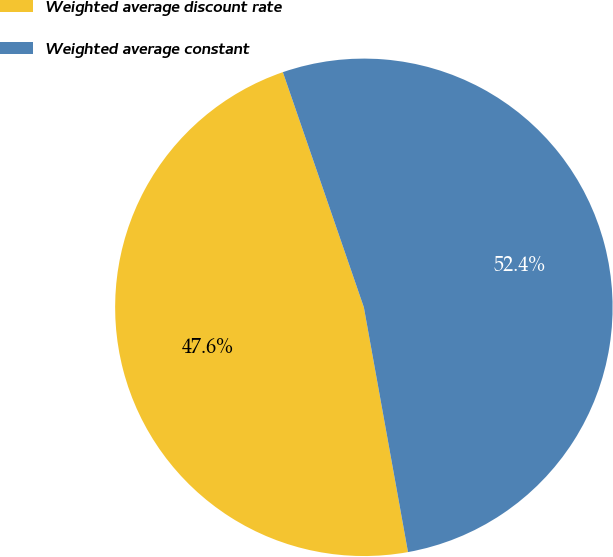<chart> <loc_0><loc_0><loc_500><loc_500><pie_chart><fcel>Weighted average discount rate<fcel>Weighted average constant<nl><fcel>47.56%<fcel>52.44%<nl></chart> 